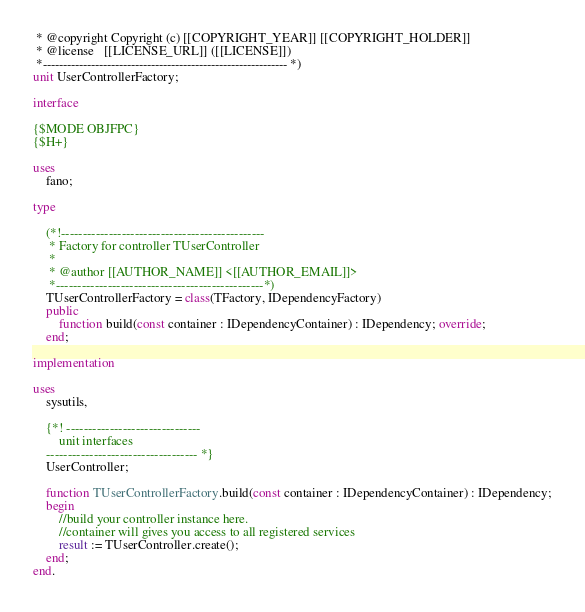<code> <loc_0><loc_0><loc_500><loc_500><_Pascal_> * @copyright Copyright (c) [[COPYRIGHT_YEAR]] [[COPYRIGHT_HOLDER]]
 * @license   [[LICENSE_URL]] ([[LICENSE]])
 *------------------------------------------------------------- *)
unit UserControllerFactory;

interface

{$MODE OBJFPC}
{$H+}

uses
    fano;

type

    (*!-----------------------------------------------
     * Factory for controller TUserController
     *
     * @author [[AUTHOR_NAME]] <[[AUTHOR_EMAIL]]>
     *------------------------------------------------*)
    TUserControllerFactory = class(TFactory, IDependencyFactory)
    public
        function build(const container : IDependencyContainer) : IDependency; override;
    end;

implementation

uses
    sysutils,

    {*! -------------------------------
        unit interfaces
    ----------------------------------- *}
    UserController;

    function TUserControllerFactory.build(const container : IDependencyContainer) : IDependency;
    begin
        //build your controller instance here.
        //container will gives you access to all registered services
        result := TUserController.create();
    end;
end.
</code> 